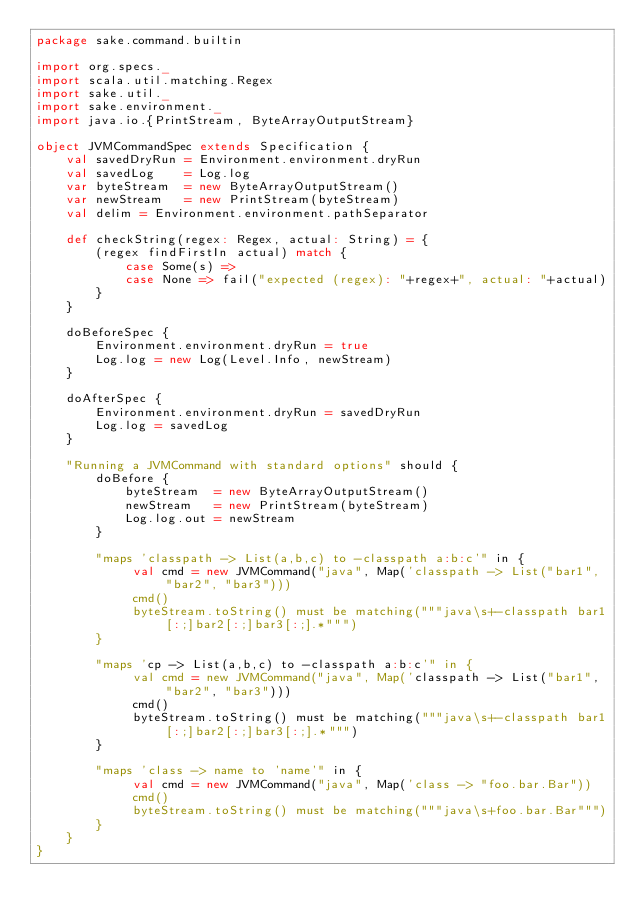Convert code to text. <code><loc_0><loc_0><loc_500><loc_500><_Scala_>package sake.command.builtin

import org.specs._
import scala.util.matching.Regex
import sake.util._
import sake.environment._
import java.io.{PrintStream, ByteArrayOutputStream}

object JVMCommandSpec extends Specification { 
    val savedDryRun = Environment.environment.dryRun
    val savedLog    = Log.log
    var byteStream  = new ByteArrayOutputStream()
    var newStream   = new PrintStream(byteStream)
    val delim = Environment.environment.pathSeparator
    
    def checkString(regex: Regex, actual: String) = {
        (regex findFirstIn actual) match {
            case Some(s) =>
            case None => fail("expected (regex): "+regex+", actual: "+actual)
        }
    }
    
    doBeforeSpec {
        Environment.environment.dryRun = true
        Log.log = new Log(Level.Info, newStream)
    }
    
    doAfterSpec {
        Environment.environment.dryRun = savedDryRun
        Log.log = savedLog
    }

    "Running a JVMCommand with standard options" should {
        doBefore {
            byteStream  = new ByteArrayOutputStream()
            newStream   = new PrintStream(byteStream)
            Log.log.out = newStream
        }

        "maps 'classpath -> List(a,b,c) to -classpath a:b:c'" in {
             val cmd = new JVMCommand("java", Map('classpath -> List("bar1", "bar2", "bar3")))
             cmd()
             byteStream.toString() must be matching("""java\s+-classpath bar1[:;]bar2[:;]bar3[:;].*""")
        }        

        "maps 'cp -> List(a,b,c) to -classpath a:b:c'" in {
             val cmd = new JVMCommand("java", Map('classpath -> List("bar1", "bar2", "bar3")))
             cmd()
             byteStream.toString() must be matching("""java\s+-classpath bar1[:;]bar2[:;]bar3[:;].*""")
        }        

        "maps 'class -> name to 'name'" in {
             val cmd = new JVMCommand("java", Map('class -> "foo.bar.Bar"))
             cmd()
             byteStream.toString() must be matching("""java\s+foo.bar.Bar""")
        }        
    }
}</code> 